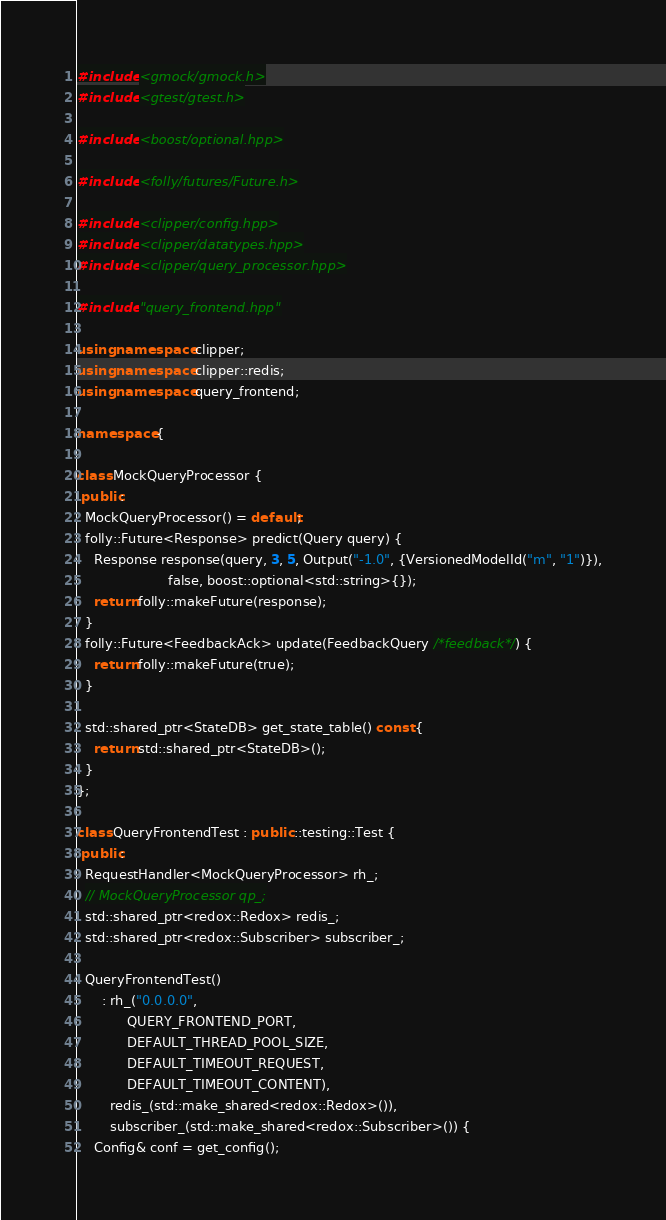Convert code to text. <code><loc_0><loc_0><loc_500><loc_500><_C++_>#include <gmock/gmock.h>
#include <gtest/gtest.h>

#include <boost/optional.hpp>

#include <folly/futures/Future.h>

#include <clipper/config.hpp>
#include <clipper/datatypes.hpp>
#include <clipper/query_processor.hpp>

#include "query_frontend.hpp"

using namespace clipper;
using namespace clipper::redis;
using namespace query_frontend;

namespace {

class MockQueryProcessor {
 public:
  MockQueryProcessor() = default;
  folly::Future<Response> predict(Query query) {
    Response response(query, 3, 5, Output("-1.0", {VersionedModelId("m", "1")}),
                      false, boost::optional<std::string>{});
    return folly::makeFuture(response);
  }
  folly::Future<FeedbackAck> update(FeedbackQuery /*feedback*/) {
    return folly::makeFuture(true);
  }

  std::shared_ptr<StateDB> get_state_table() const {
    return std::shared_ptr<StateDB>();
  }
};

class QueryFrontendTest : public ::testing::Test {
 public:
  RequestHandler<MockQueryProcessor> rh_;
  // MockQueryProcessor qp_;
  std::shared_ptr<redox::Redox> redis_;
  std::shared_ptr<redox::Subscriber> subscriber_;

  QueryFrontendTest()
      : rh_("0.0.0.0",
            QUERY_FRONTEND_PORT,
            DEFAULT_THREAD_POOL_SIZE,
            DEFAULT_TIMEOUT_REQUEST,
            DEFAULT_TIMEOUT_CONTENT),
        redis_(std::make_shared<redox::Redox>()),
        subscriber_(std::make_shared<redox::Subscriber>()) {
    Config& conf = get_config();</code> 